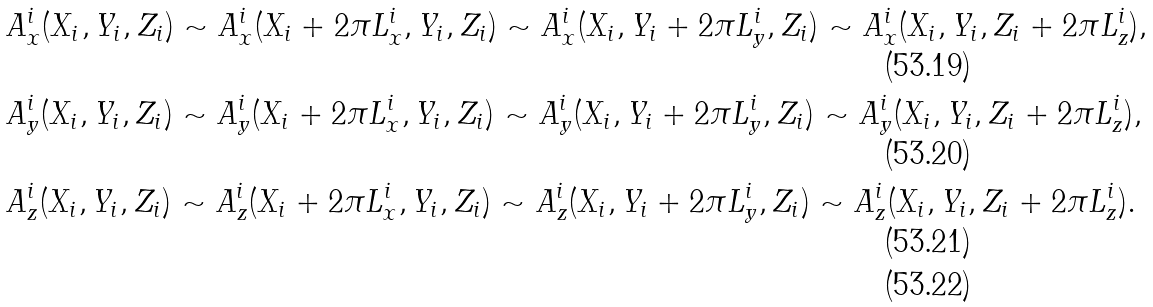Convert formula to latex. <formula><loc_0><loc_0><loc_500><loc_500>& A _ { x } ^ { i } ( X _ { i } , Y _ { i } , Z _ { i } ) \sim A _ { x } ^ { i } ( X _ { i } + 2 \pi L _ { x } ^ { i } , Y _ { i } , Z _ { i } ) \sim A _ { x } ^ { i } ( X _ { i } , Y _ { i } + 2 \pi L _ { y } ^ { i } , Z _ { i } ) \sim A _ { x } ^ { i } ( X _ { i } , Y _ { i } , Z _ { i } + 2 \pi L _ { z } ^ { i } ) , \\ & A _ { y } ^ { i } ( X _ { i } , Y _ { i } , Z _ { i } ) \sim A _ { y } ^ { i } ( X _ { i } + 2 \pi L _ { x } ^ { i } , Y _ { i } , Z _ { i } ) \sim A _ { y } ^ { i } ( X _ { i } , Y _ { i } + 2 \pi L _ { y } ^ { i } , Z _ { i } ) \sim A _ { y } ^ { i } ( X _ { i } , Y _ { i } , Z _ { i } + 2 \pi L _ { z } ^ { i } ) , \\ & A _ { z } ^ { i } ( X _ { i } , Y _ { i } , Z _ { i } ) \sim A _ { z } ^ { i } ( X _ { i } + 2 \pi L _ { x } ^ { i } , Y _ { i } , Z _ { i } ) \sim A _ { z } ^ { i } ( X _ { i } , Y _ { i } + 2 \pi L _ { y } ^ { i } , Z _ { i } ) \sim A _ { z } ^ { i } ( X _ { i } , Y _ { i } , Z _ { i } + 2 \pi L _ { z } ^ { i } ) . \\</formula> 